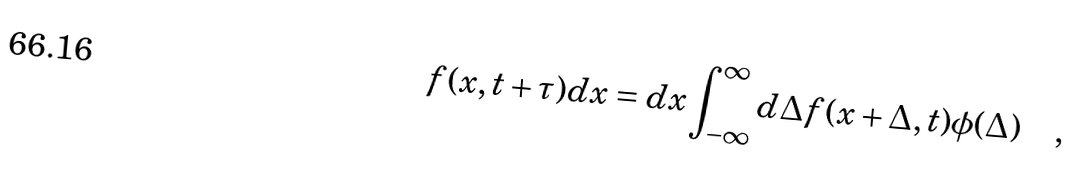Convert formula to latex. <formula><loc_0><loc_0><loc_500><loc_500>f ( x , t + \tau ) d x = d x \int _ { - \infty } ^ { \infty } d \Delta f ( x + \Delta , t ) \phi ( \Delta ) \quad ,</formula> 